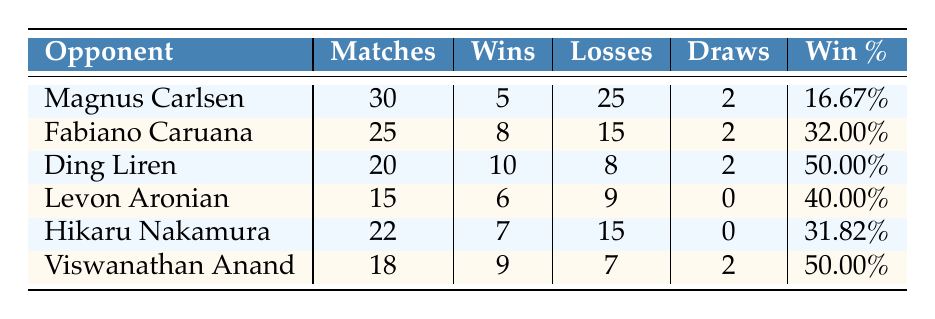What's the win percentage against Magnus Carlsen? The table shows that there is a specific entry for Magnus Carlsen. The win percentage documented is 16.67%.
Answer: 16.67% How many matches were played against Fabiano Caruana? By looking at the row for Fabiano Caruana, we can see that the number of matches played is listed as 25.
Answer: 25 Who has the highest win percentage among the opponents listed? To determine the highest win percentage, we examine the win percentages of all players. Ding Liren and Viswanathan Anand both have a win percentage of 50.00%, which is the highest in the table.
Answer: Ding Liren and Viswanathan Anand What is the total number of wins against Hikaru Nakamura and Levon Aronian combined? For Hikaru Nakamura, the wins are 7, and for Levon Aronian, the wins are 6. Adding these together gives us 7 + 6 = 13.
Answer: 13 Is there a player against whom the number of losses is greater than the number of matches played? By reviewing the losses for each player, we can verify that no player has losses that exceed the number of matches played, as all losses are less than or equal to matches played.
Answer: No What is the average number of draws across all opponents? To find the average number of draws, we add the draws for each opponent: 2 (Carlsen) + 2 (Caruana) + 2 (Ding) + 0 (Aronian) + 0 (Nakamura) + 2 (Anand) = 8 draws. Since there are 6 opponents, the average is 8/6 = 1.33.
Answer: 1.33 How many players have a win percentage below 40%? The players with a win percentage below 40% are Magnus Carlsen (16.67%), Fabiano Caruana (32.00%), Hikaru Nakamura (31.82%), and Levon Aronian (40.00%). Since Aronian is not below, it leaves three players.
Answer: 3 What is the difference in the number of wins between Ding Liren and Hikaru Nakamura? Ding Liren has 10 wins, while Hikaru Nakamura has 7 wins. The difference is calculated as 10 - 7 = 3.
Answer: 3 How many total matches have been played against all the listed opponents? To find the total number of matches played, we add the matches together: 30 (Carlsen) + 25 (Caruana) + 20 (Liren) + 15 (Aronian) + 22 (Nakamura) + 18 (Anand) = 130 matches.
Answer: 130 